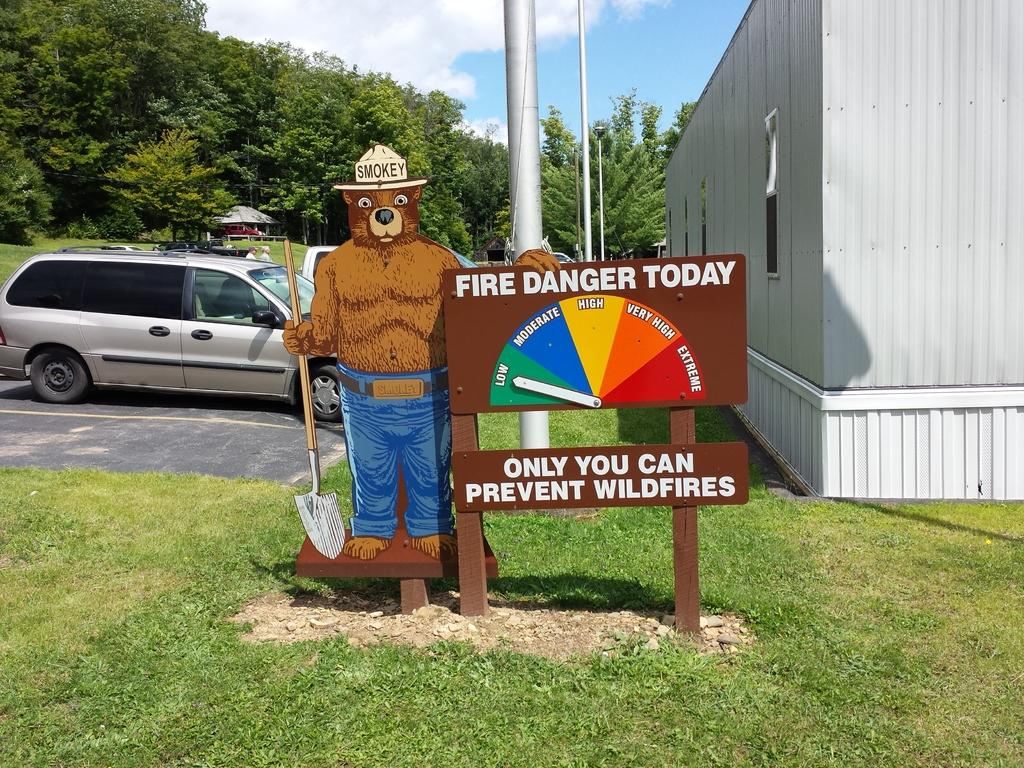What animal can be seen in the image? There is a bear in the image. What is written on the board in the image? There is a board with text in the image. What can be seen in the distance in the image? Cars, trees, a shed, poles, and a cloudy sky are visible in the background of the image. What type of print can be seen on the bear's fur in the image? There is no print visible on the bear's fur in the image; it appears to be a natural bear. 